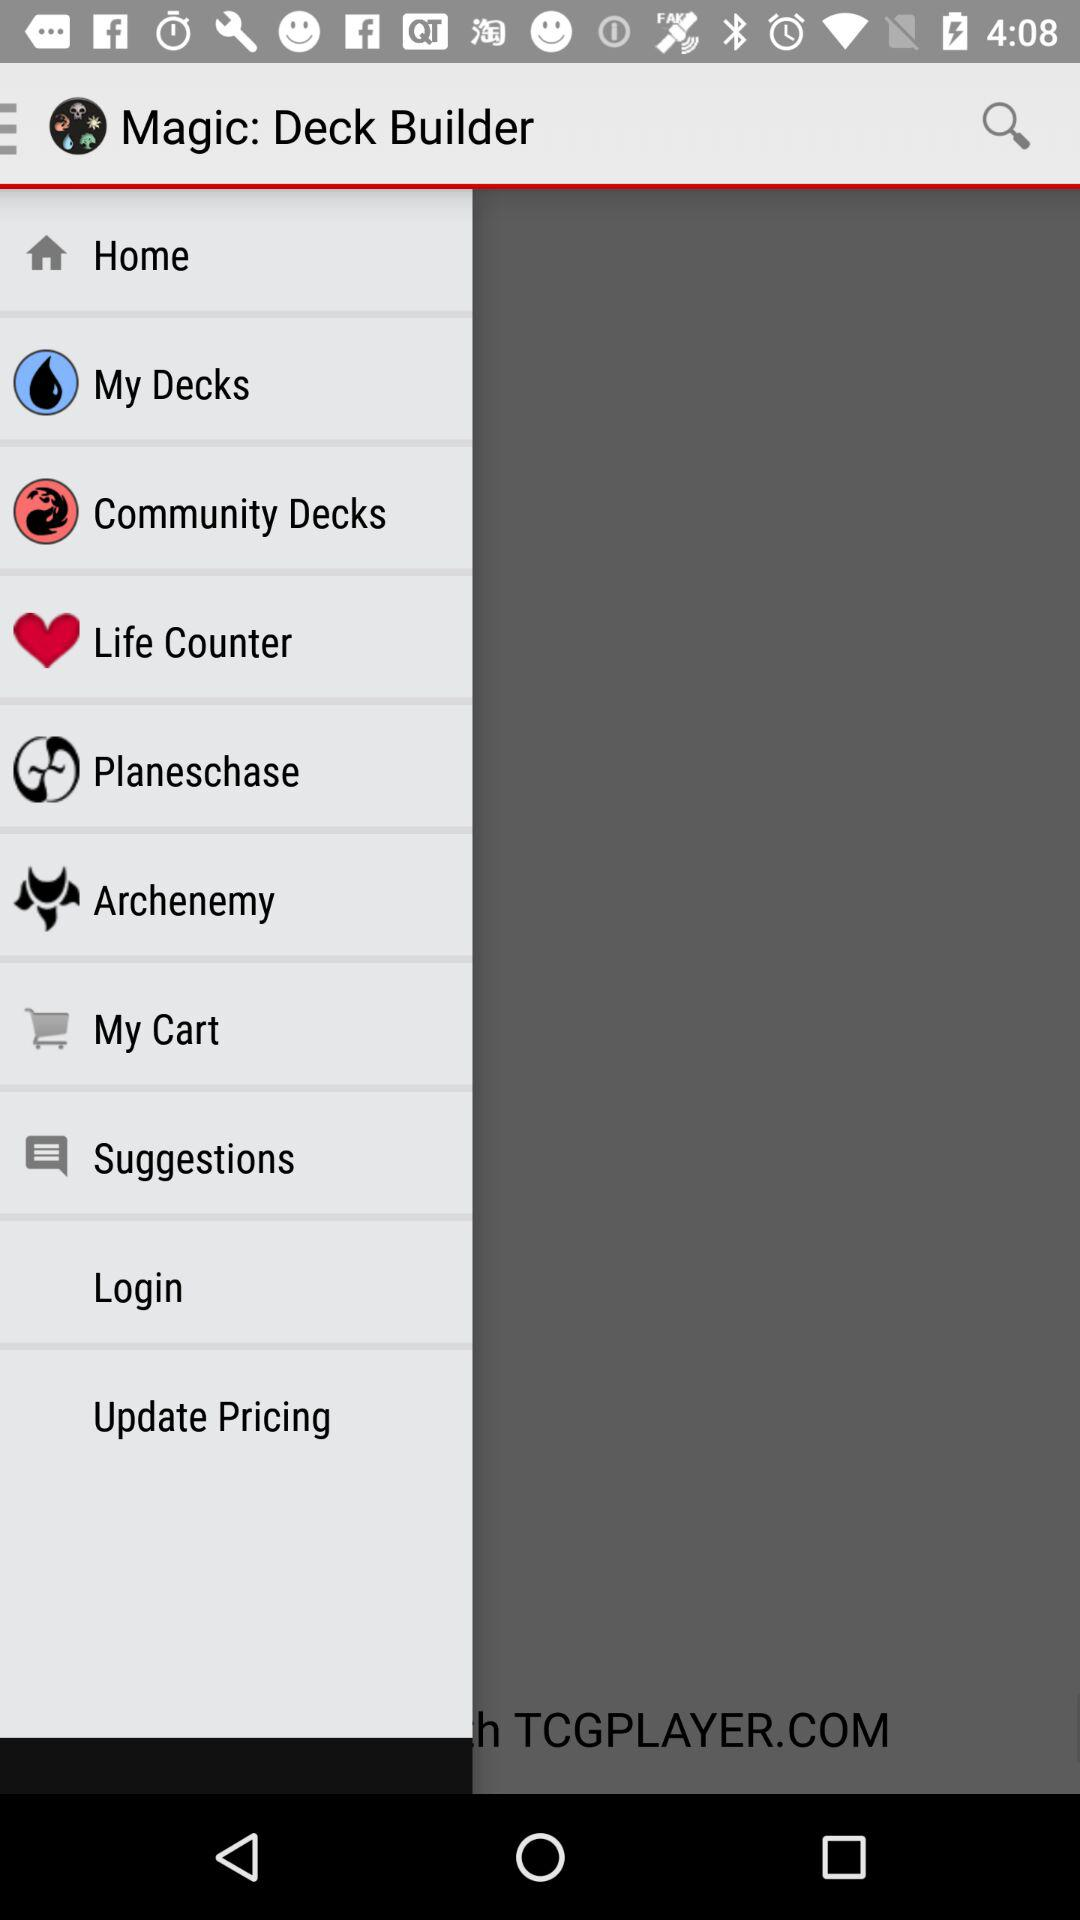How many pages are there in total? There is only 1 page. 